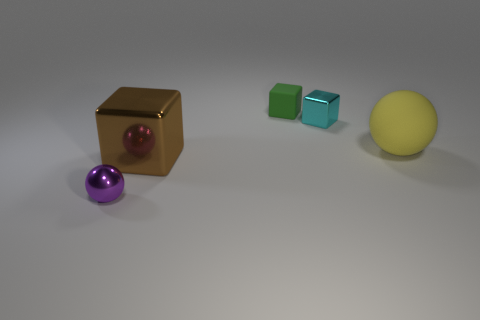What number of large objects are in front of the ball that is behind the purple metallic thing?
Offer a terse response. 1. Does the purple metallic ball have the same size as the block in front of the cyan block?
Ensure brevity in your answer.  No. Is there a green shiny cube of the same size as the purple shiny ball?
Your answer should be compact. No. How many things are large gray shiny things or small objects?
Provide a short and direct response. 3. Do the cube in front of the yellow matte ball and the metallic cube behind the yellow thing have the same size?
Offer a terse response. No. Is there a large yellow matte object of the same shape as the green thing?
Give a very brief answer. No. Is the number of purple metallic objects that are to the right of the cyan block less than the number of purple things?
Provide a short and direct response. Yes. Is the shape of the yellow object the same as the tiny purple thing?
Keep it short and to the point. Yes. How big is the sphere behind the tiny ball?
Keep it short and to the point. Large. What is the size of the green cube that is the same material as the large yellow thing?
Your answer should be very brief. Small. 